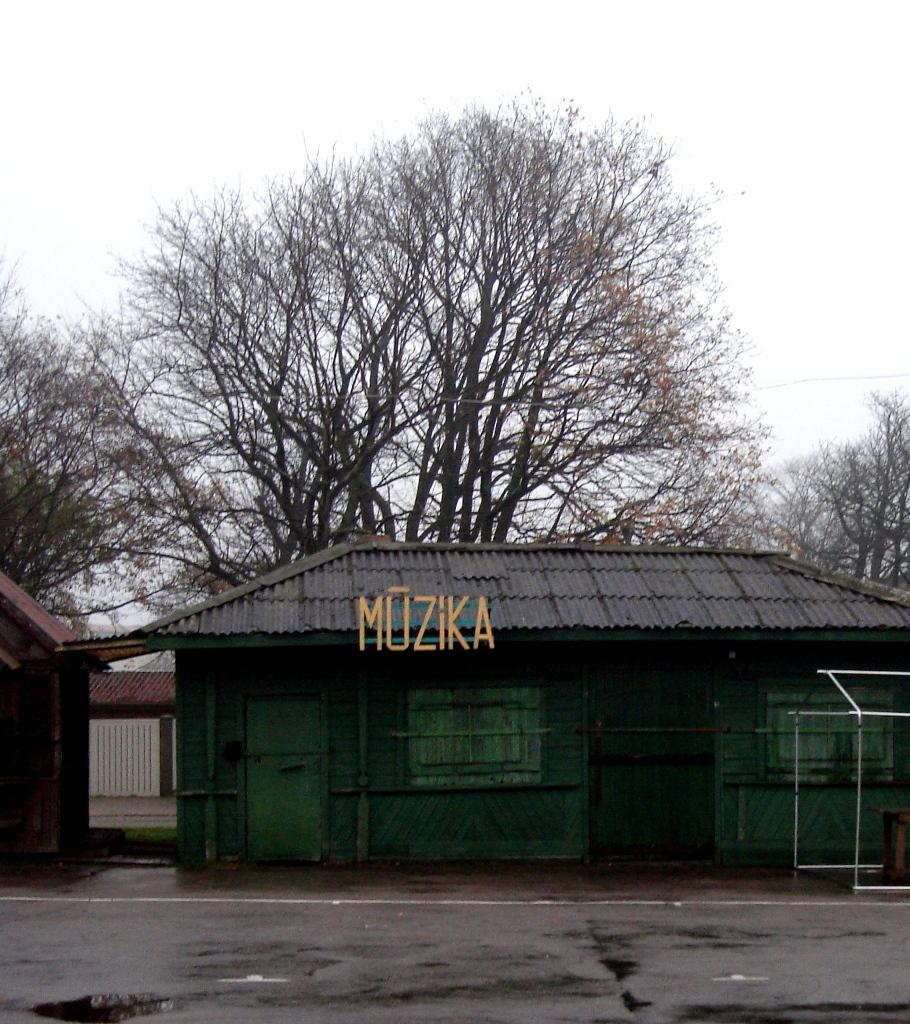What is the main feature of the image? There is a road in the image. How many houses can be seen in the image? There are two houses in the image. What are the colors of the houses? One house is green in color, and the other house is brown in color. What can be seen in the background of the image? There are trees and the sky visible in the background of the image. What type of card is being used to fill the hole in the image? There is no hole or card present in the image. 